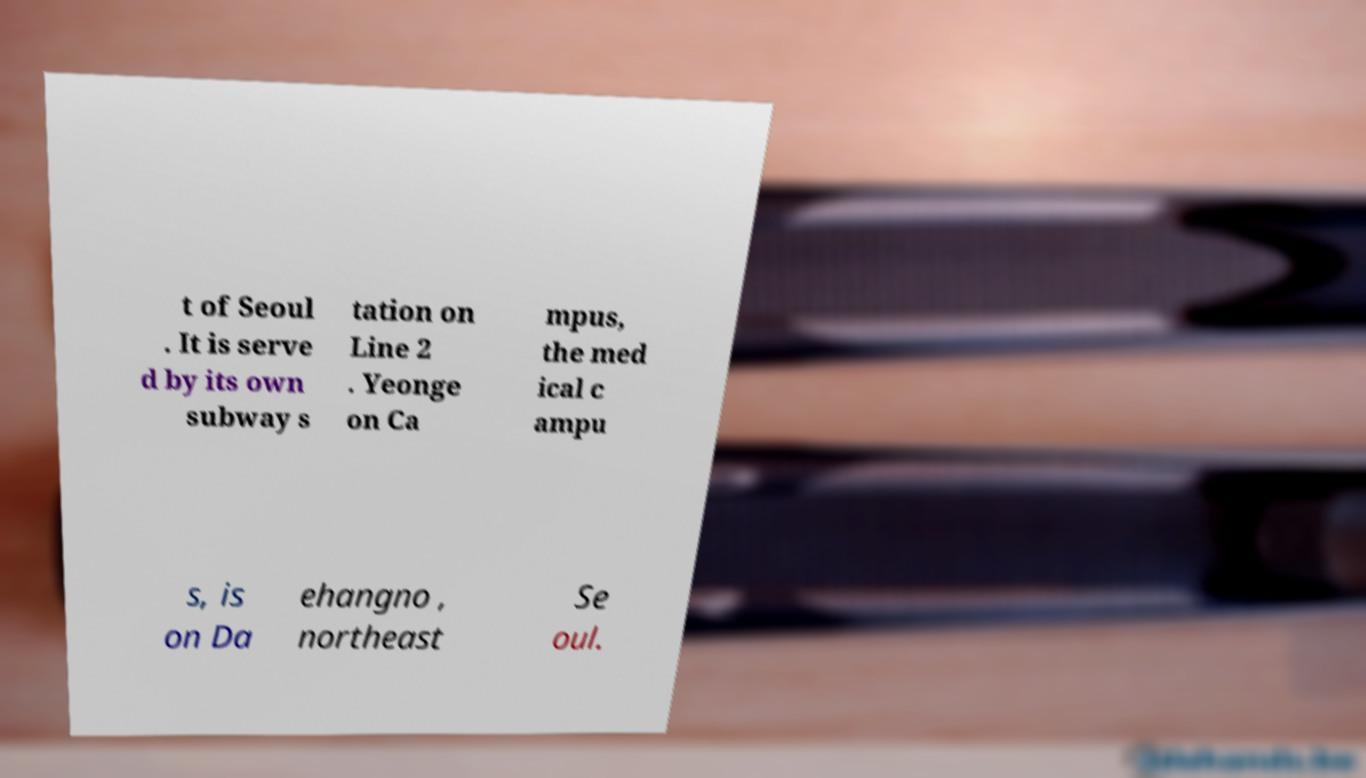Please read and relay the text visible in this image. What does it say? t of Seoul . It is serve d by its own subway s tation on Line 2 . Yeonge on Ca mpus, the med ical c ampu s, is on Da ehangno , northeast Se oul. 